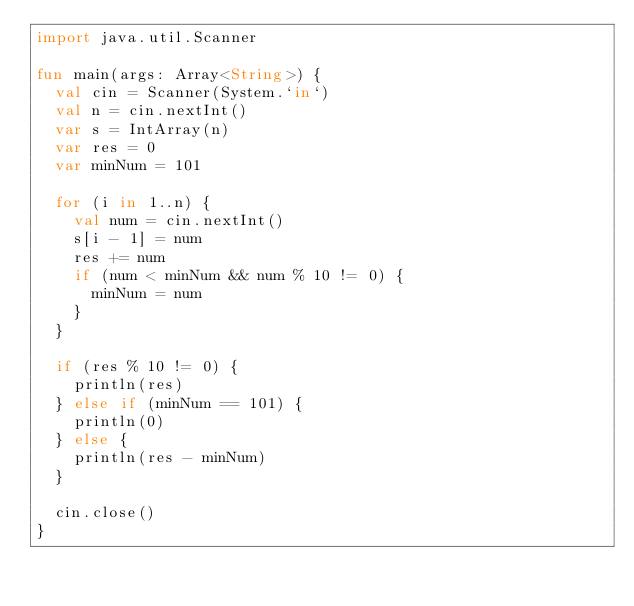Convert code to text. <code><loc_0><loc_0><loc_500><loc_500><_Kotlin_>import java.util.Scanner

fun main(args: Array<String>) {
  val cin = Scanner(System.`in`)
  val n = cin.nextInt()
  var s = IntArray(n)
  var res = 0
  var minNum = 101

  for (i in 1..n) {
    val num = cin.nextInt()
    s[i - 1] = num
    res += num
    if (num < minNum && num % 10 != 0) {
      minNum = num
    }
  }

  if (res % 10 != 0) {
    println(res)
  } else if (minNum == 101) {
    println(0)
  } else {
    println(res - minNum)
  }

  cin.close()
}</code> 